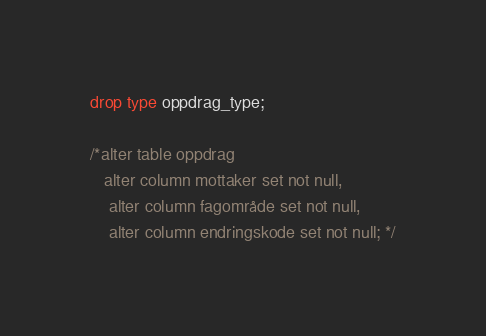<code> <loc_0><loc_0><loc_500><loc_500><_SQL_>drop type oppdrag_type;

/*alter table oppdrag
   alter column mottaker set not null,
    alter column fagområde set not null,
    alter column endringskode set not null; */
</code> 